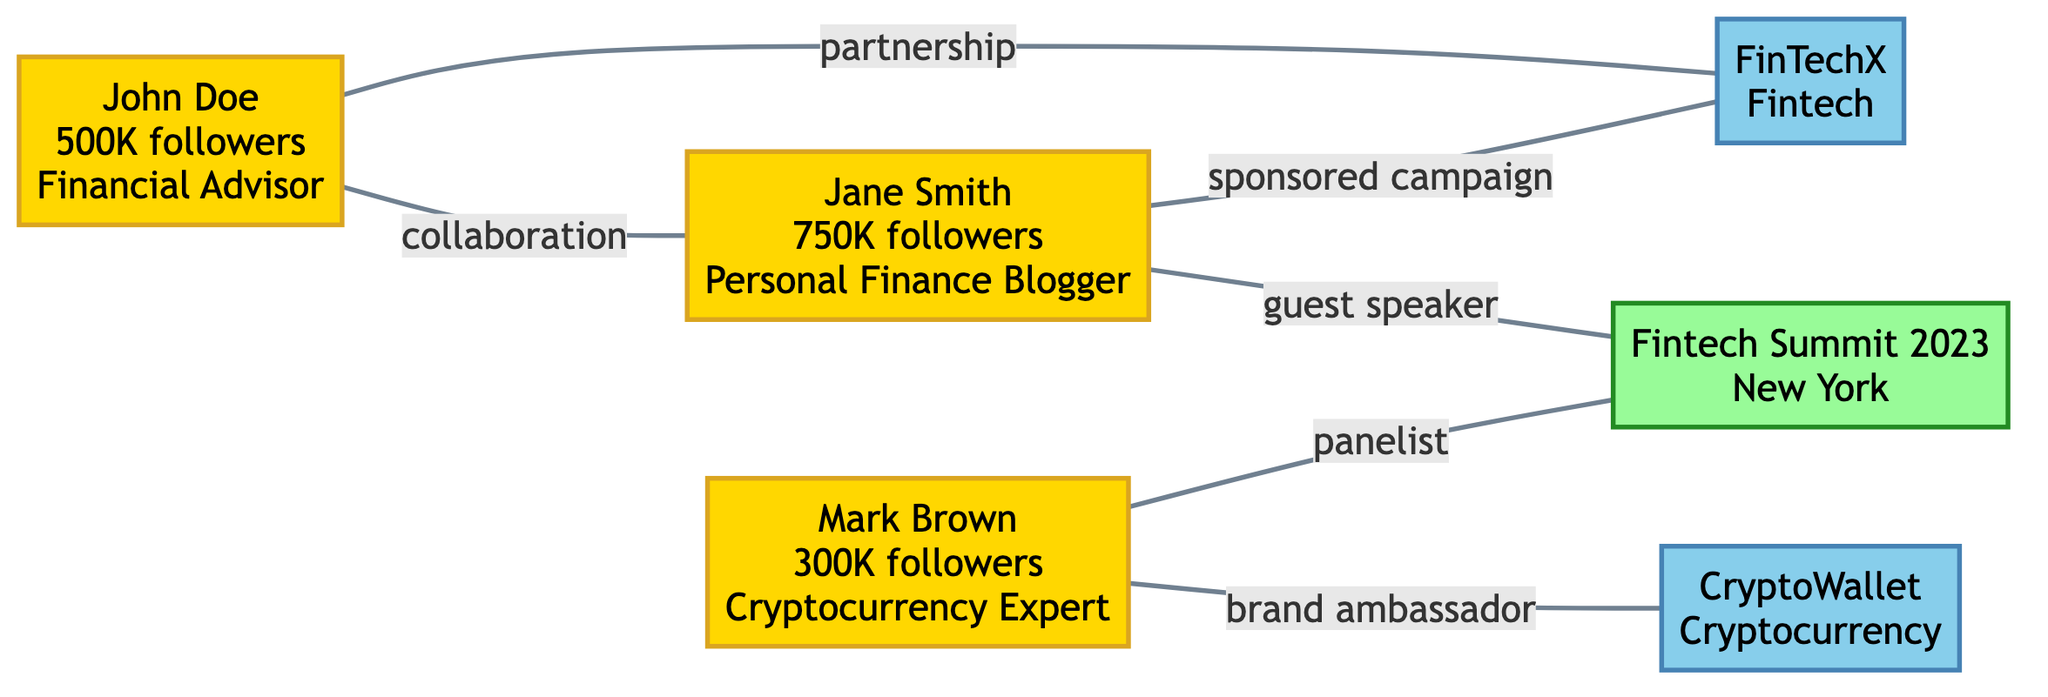What is the total number of influencers in the diagram? There are three nodes classified as influencers in the diagram: John Doe, Jane Smith, and Mark Brown.
Answer: 3 Who has the highest number of followers? By comparing the numbers listed for each influencer, Jane Smith has 750,000 followers, which is the highest among the three.
Answer: Jane Smith What relationship does Mark Brown have with the brand CryptoWallet? The diagram shows a direct connection labeled 'brand ambassador' between Mark Brown and CryptoWallet.
Answer: brand ambassador How many events are represented in the graph? The diagram includes one event node, which is the Fintech Summit 2023.
Answer: 1 Which influencer is connected to the Fintech Summit 2023 as a panelist? From the diagram, it is clear that Mark Brown has the relationship of 'panelist' with the event Fintech Summit 2023.
Answer: Mark Brown How many total links are there in the diagram? The diagram shows a total of six direct connections (links) between nodes.
Answer: 6 What type of relationship do John Doe and Jane Smith share? The connection between John Doe and Jane Smith is labeled as 'collaboration' in the diagram.
Answer: collaboration Which influencer is a guest speaker at the event? The diagram indicates that Jane Smith has the relationship of 'guest speaker' with the Fintech Summit 2023.
Answer: Jane Smith Which brand does John Doe have a partnership with? The link from John Doe indicates that his relationship is a 'partnership' with FinTechX.
Answer: FinTechX 